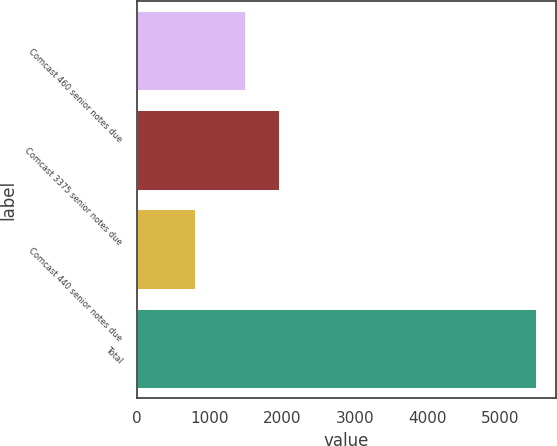Convert chart. <chart><loc_0><loc_0><loc_500><loc_500><bar_chart><fcel>Comcast 460 senior notes due<fcel>Comcast 3375 senior notes due<fcel>Comcast 440 senior notes due<fcel>Total<nl><fcel>1490<fcel>1959<fcel>800<fcel>5490<nl></chart> 